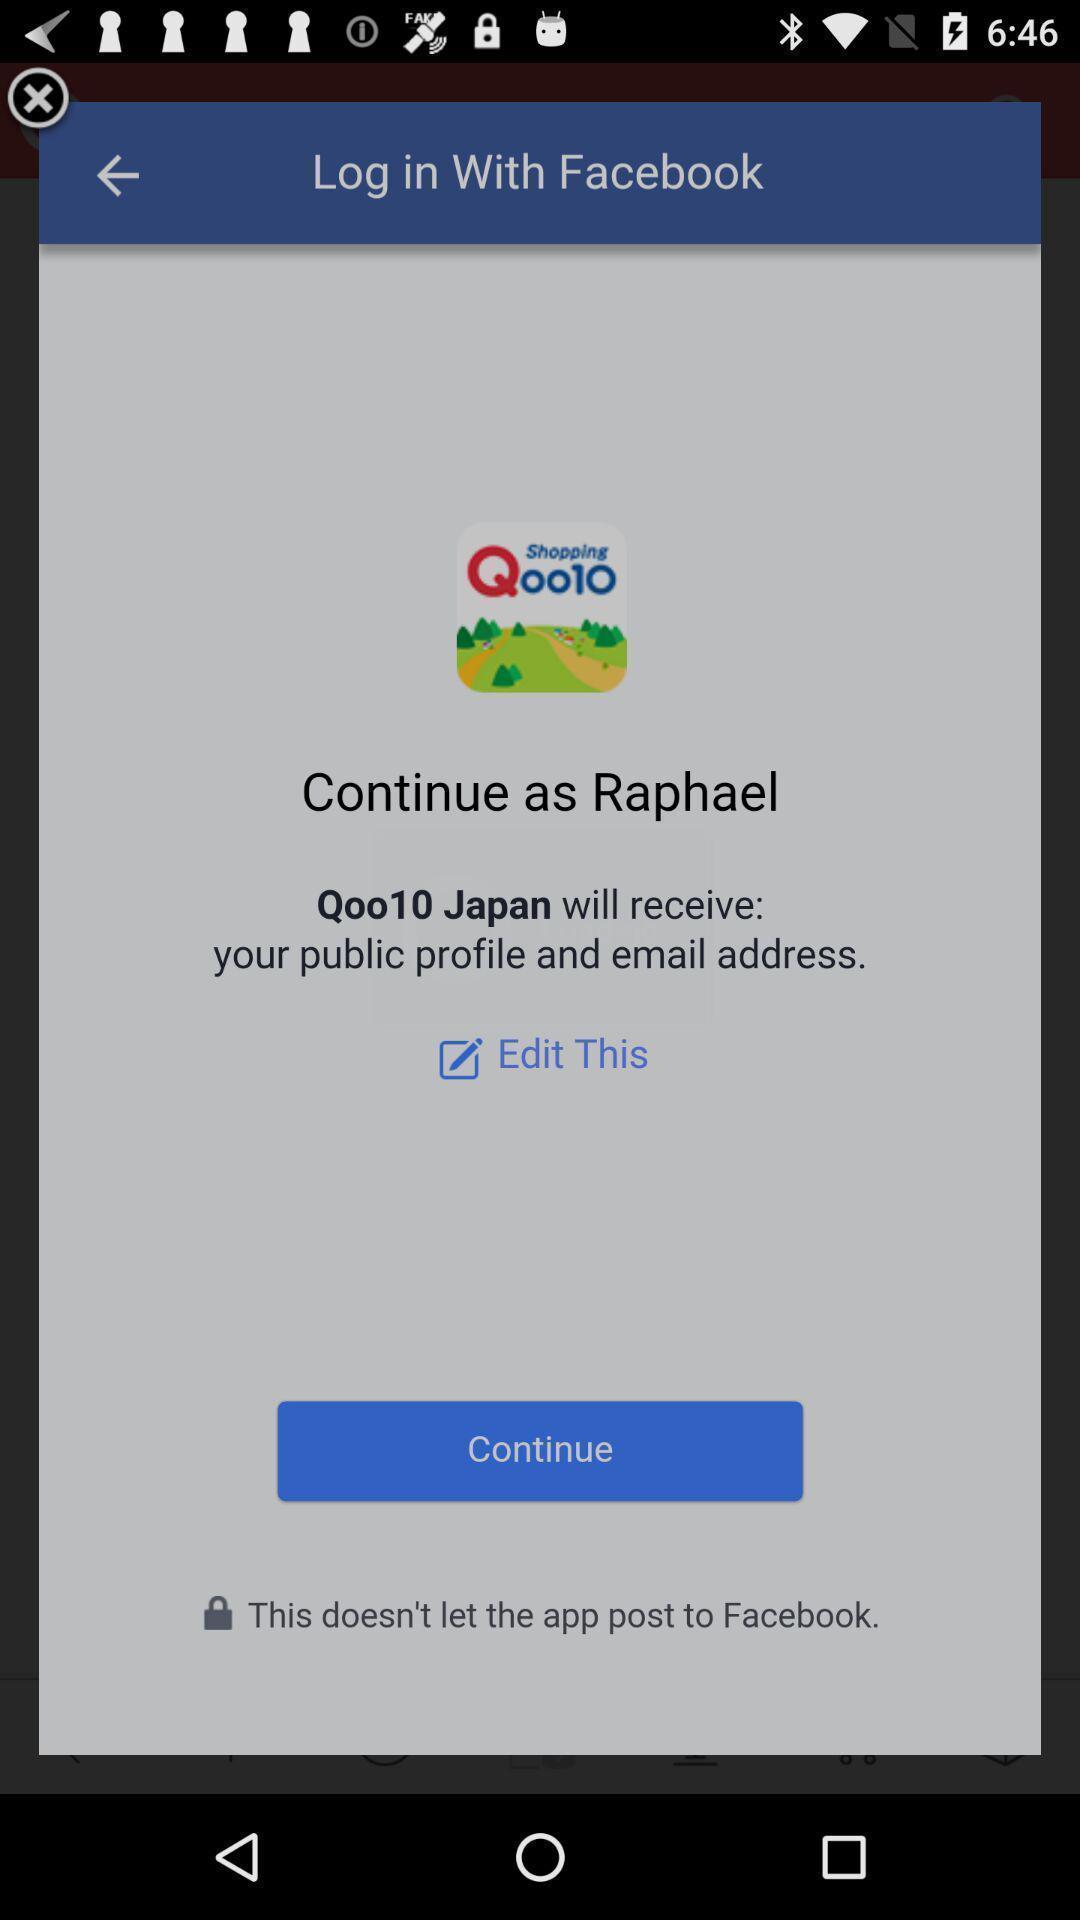What is the overall content of this screenshot? Pop up suggesting to continue with an existing account. 